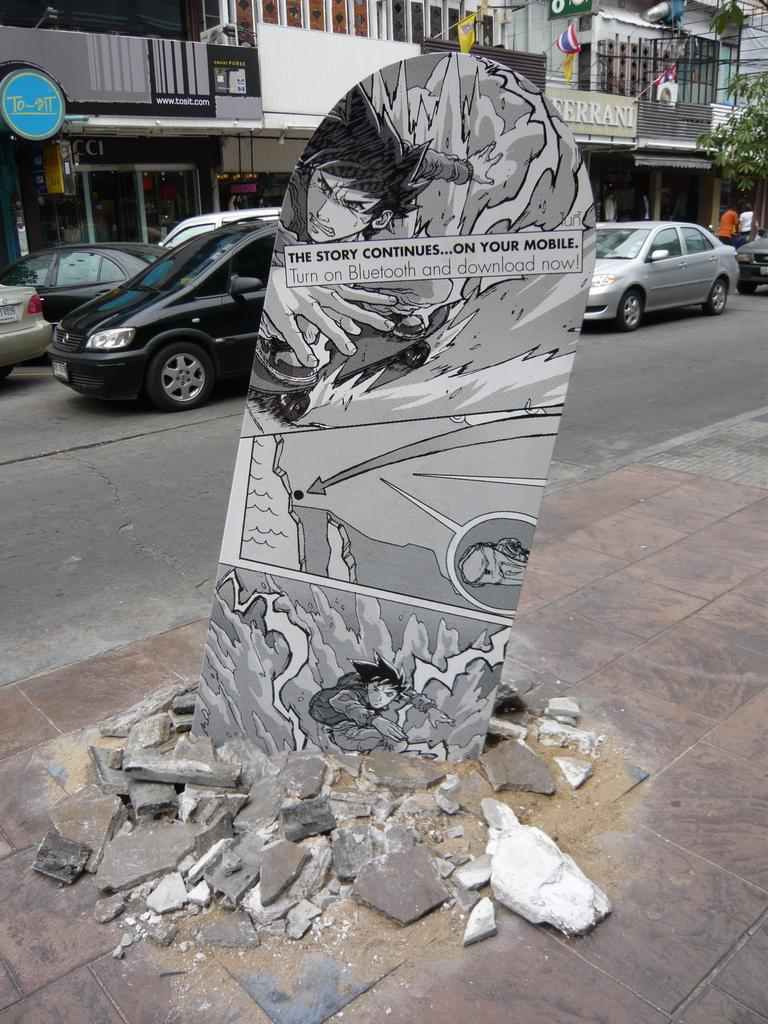What is placed on the footpath in the image? There is a board on the footpath in the image. What can be seen on the road in the image? There are cars on the road in the image. What structure is visible in the image? There is a building visible in the image. How many crows are sitting on the building in the image? There are no crows present in the image; it only features a board on the footpath, cars on the road, and a building. What type of fork is used to hold the board on the footpath? There is no fork present in the image; the board is simply placed on the footpath. 